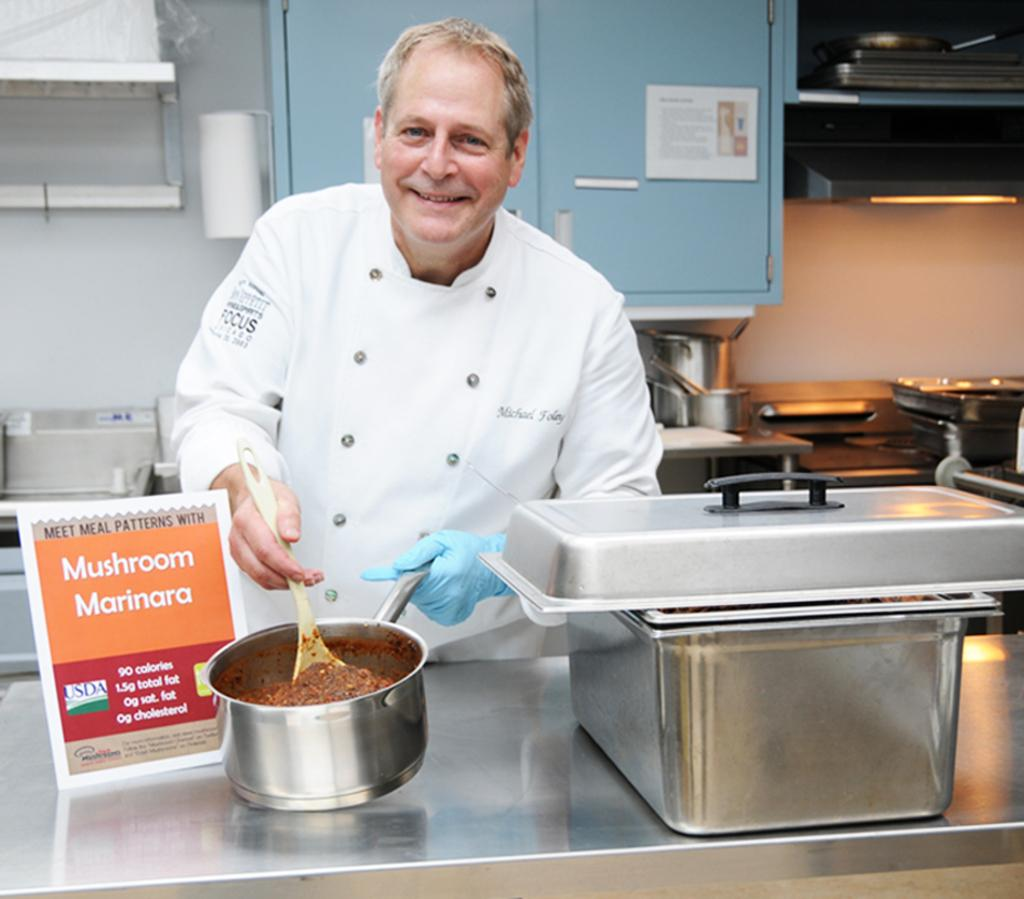<image>
Give a short and clear explanation of the subsequent image. A chief cooking mushroom marinara with the brand Focus on arm of shirt. 